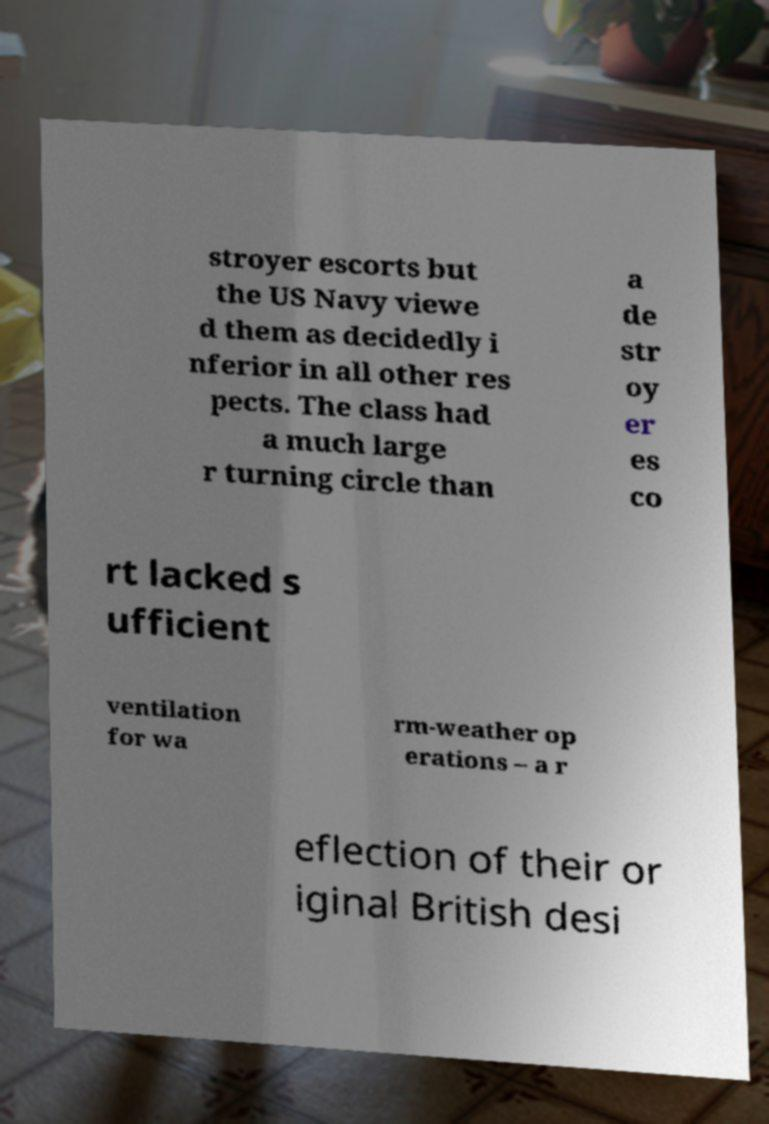For documentation purposes, I need the text within this image transcribed. Could you provide that? stroyer escorts but the US Navy viewe d them as decidedly i nferior in all other res pects. The class had a much large r turning circle than a de str oy er es co rt lacked s ufficient ventilation for wa rm-weather op erations – a r eflection of their or iginal British desi 